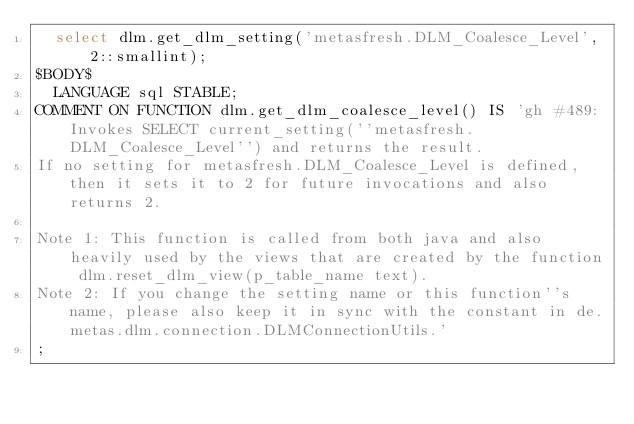Convert code to text. <code><loc_0><loc_0><loc_500><loc_500><_SQL_>	select dlm.get_dlm_setting('metasfresh.DLM_Coalesce_Level', 2::smallint);
$BODY$
  LANGUAGE sql STABLE;
COMMENT ON FUNCTION dlm.get_dlm_coalesce_level() IS 'gh #489: Invokes SELECT current_setting(''metasfresh.DLM_Coalesce_Level'') and returns the result. 
If no setting for metasfresh.DLM_Coalesce_Level is defined, then it sets it to 2 for future invocations and also returns 2.

Note 1: This function is called from both java and also heavily used by the views that are created by the function dlm.reset_dlm_view(p_table_name text).
Note 2: If you change the setting name or this function''s name, please also keep it in sync with the constant in de.metas.dlm.connection.DLMConnectionUtils.'
;
</code> 